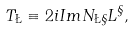Convert formula to latex. <formula><loc_0><loc_0><loc_500><loc_500>T _ { \L } \equiv 2 i I m N _ { \L \S } L ^ { \S } ,</formula> 